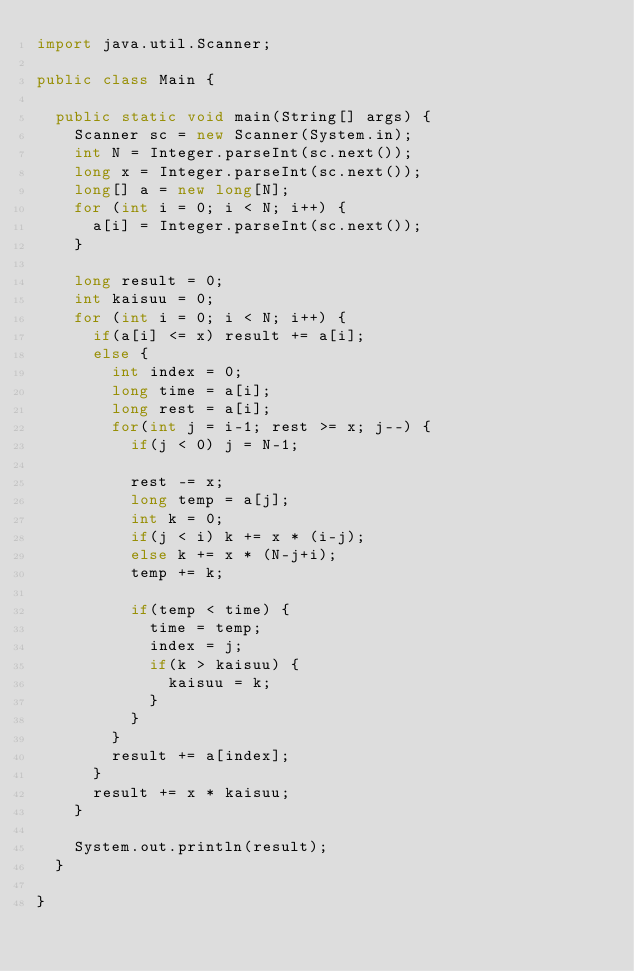<code> <loc_0><loc_0><loc_500><loc_500><_Java_>import java.util.Scanner;

public class Main {

	public static void main(String[] args) {
		Scanner sc = new Scanner(System.in);
		int N = Integer.parseInt(sc.next());
		long x = Integer.parseInt(sc.next());
		long[] a = new long[N];
		for (int i = 0; i < N; i++) {
			a[i] = Integer.parseInt(sc.next());
		}

		long result = 0;
		int kaisuu = 0;
		for (int i = 0; i < N; i++) {
			if(a[i] <= x) result += a[i];
			else {
				int index = 0;
				long time = a[i];
				long rest = a[i];
				for(int j = i-1; rest >= x; j--) {
					if(j < 0) j = N-1;

					rest -= x;
					long temp = a[j];
					int k = 0;
					if(j < i) k += x * (i-j);
					else k += x * (N-j+i);
					temp += k;

					if(temp < time) {
						time = temp;
						index = j;
						if(k > kaisuu) {
							kaisuu = k;
						}
					}
				}
				result += a[index];
			}
			result += x * kaisuu;
		}

		System.out.println(result);
	}

}
</code> 